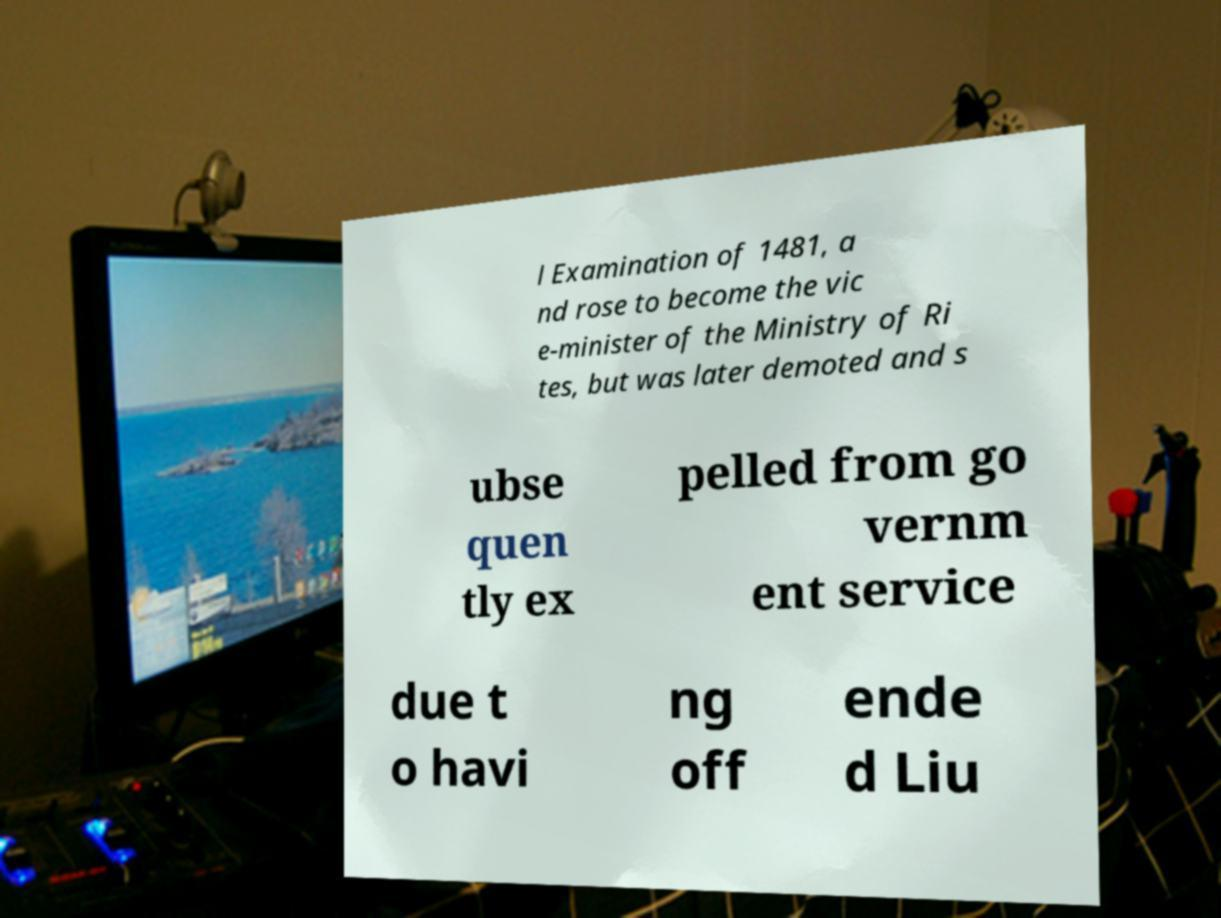There's text embedded in this image that I need extracted. Can you transcribe it verbatim? l Examination of 1481, a nd rose to become the vic e-minister of the Ministry of Ri tes, but was later demoted and s ubse quen tly ex pelled from go vernm ent service due t o havi ng off ende d Liu 